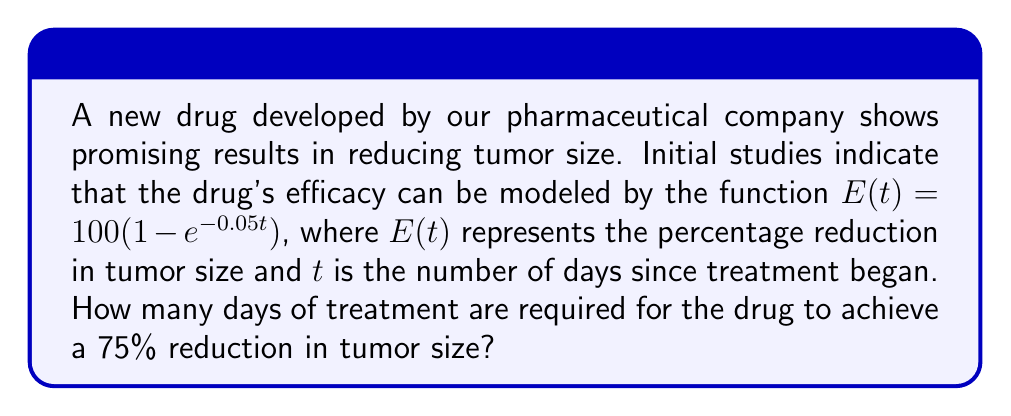Give your solution to this math problem. To solve this problem, we need to follow these steps:

1) We want to find $t$ when $E(t) = 75$. So, we set up the equation:
   $$75 = 100(1 - e^{-0.05t})$$

2) Divide both sides by 100:
   $$0.75 = 1 - e^{-0.05t}$$

3) Subtract both sides from 1:
   $$0.25 = e^{-0.05t}$$

4) Take the natural logarithm of both sides:
   $$\ln(0.25) = -0.05t$$

5) Simplify the left side:
   $$-1.3863 = -0.05t$$

6) Divide both sides by -0.05:
   $$27.7259 = t$$

7) Round to the nearest whole number of days:
   $$t \approx 28$$

Therefore, it takes approximately 28 days of treatment to achieve a 75% reduction in tumor size.
Answer: 28 days 